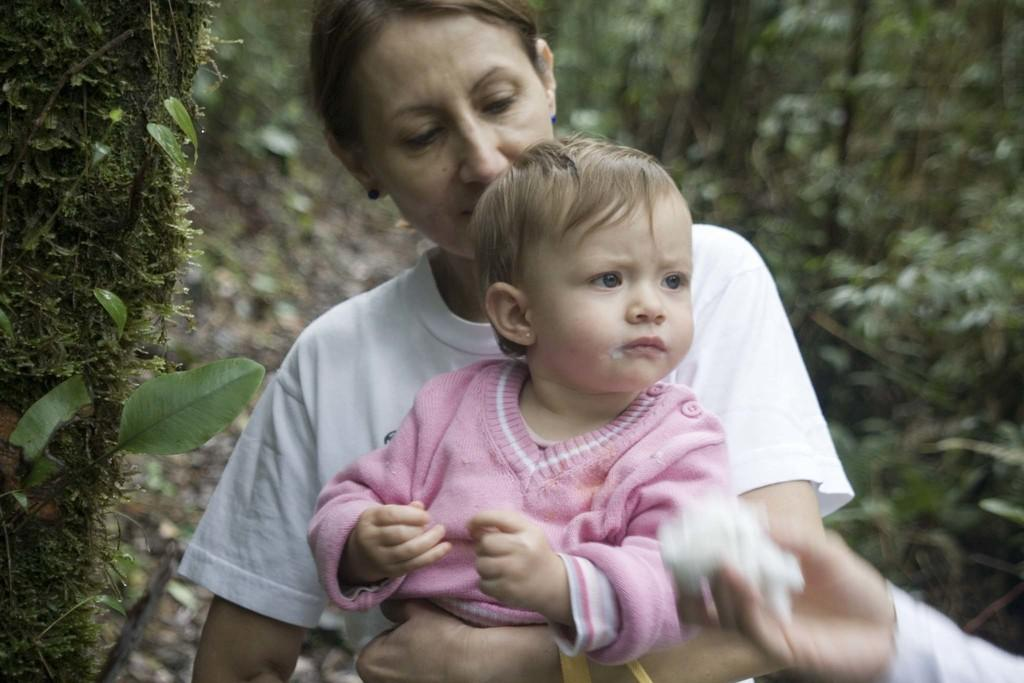What is the woman in the image holding? The woman is holding a baby in the image. Can you describe the hand visible on the right side of the image? There is a human hand on the right side of the image. What can be seen in the background of the image? Plants are visible in the background of the image. What type of beginner's stone can be seen in the woman's hand in the image? There is no stone present in the image, and the woman's hand is holding a baby, not a stone. What kind of animal is visible in the background of the image? There are no animals visible in the image; only plants can be seen in the background. 